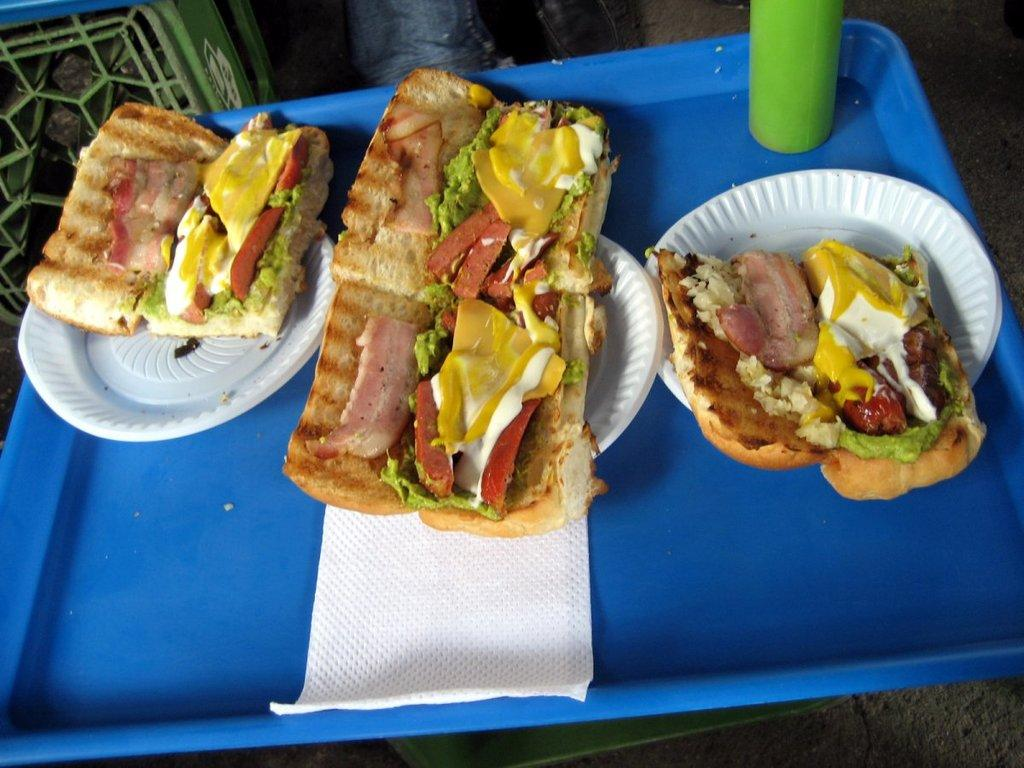What is present on the plates in the image? There is food in the plates in the image. What items are available for cleaning or wiping in the image? Napkins are present in the image for cleaning or wiping. What can be seen on the table in the image? There is a bottle on the table in the image. What is visible on the left side of the image? There are other unspecified items on the left side of the image. What type of credit card is visible in the image? There is no credit card present in the image. Can you see a star in the image? There is no star visible in the image. 